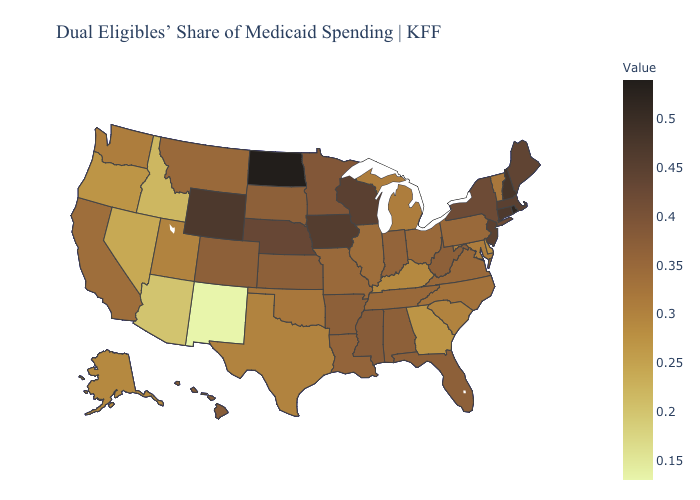Does Kansas have a lower value than Texas?
Give a very brief answer. No. Which states have the lowest value in the MidWest?
Keep it brief. Michigan. Among the states that border Iowa , does Illinois have the lowest value?
Be succinct. Yes. Does Louisiana have a higher value than Massachusetts?
Quick response, please. No. Which states hav the highest value in the Northeast?
Write a very short answer. Rhode Island. Does Illinois have the highest value in the MidWest?
Write a very short answer. No. 